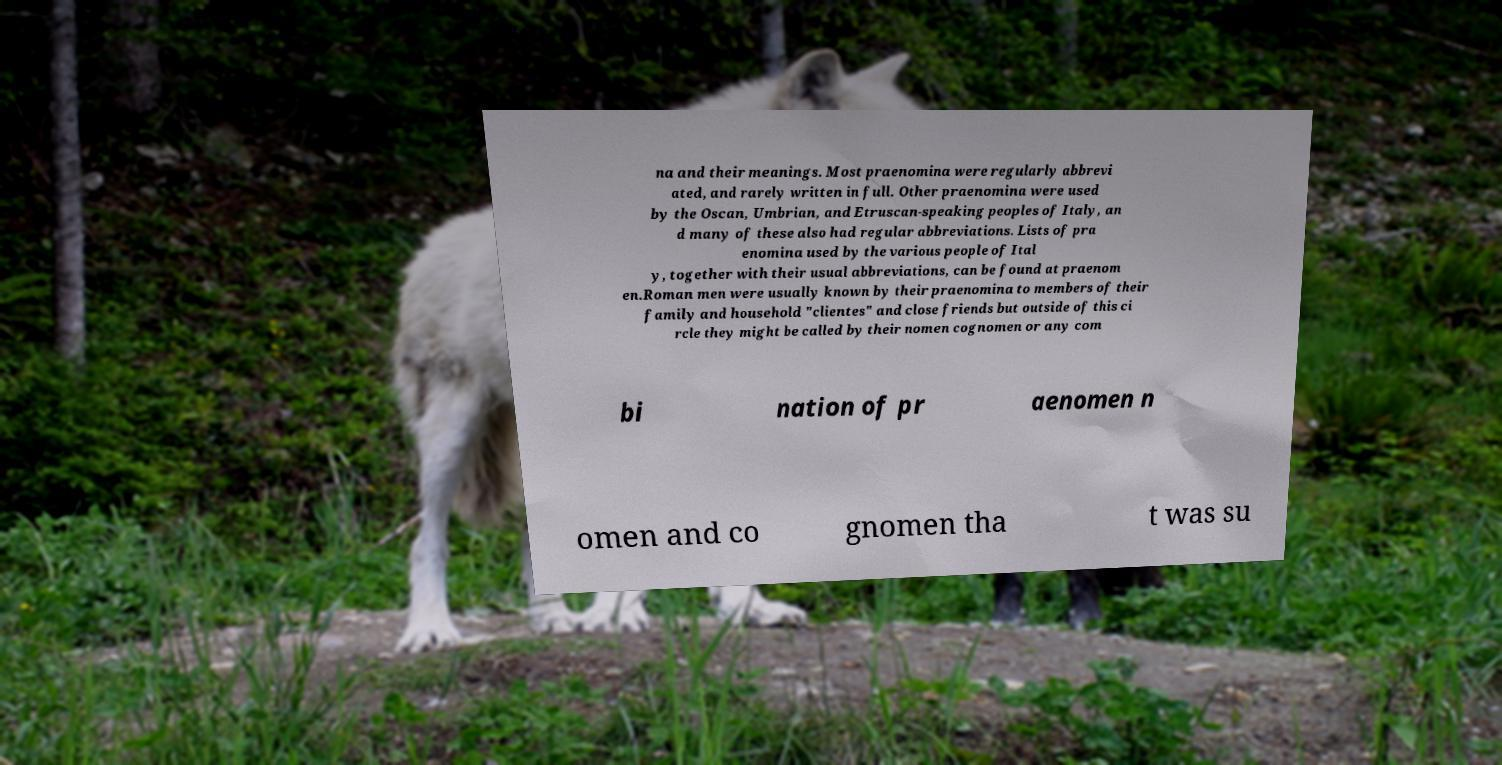I need the written content from this picture converted into text. Can you do that? na and their meanings. Most praenomina were regularly abbrevi ated, and rarely written in full. Other praenomina were used by the Oscan, Umbrian, and Etruscan-speaking peoples of Italy, an d many of these also had regular abbreviations. Lists of pra enomina used by the various people of Ital y, together with their usual abbreviations, can be found at praenom en.Roman men were usually known by their praenomina to members of their family and household "clientes" and close friends but outside of this ci rcle they might be called by their nomen cognomen or any com bi nation of pr aenomen n omen and co gnomen tha t was su 